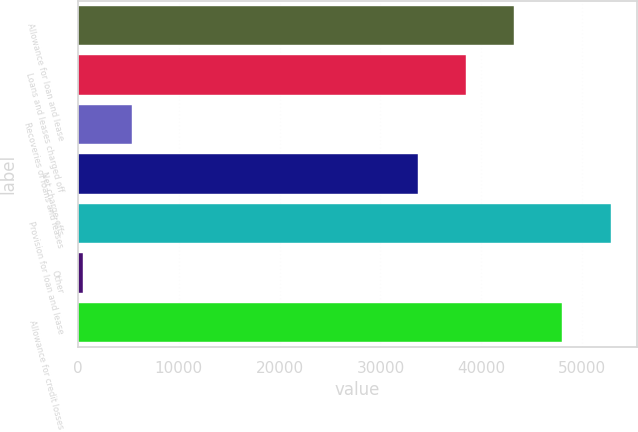Convert chart. <chart><loc_0><loc_0><loc_500><loc_500><bar_chart><fcel>Allowance for loan and lease<fcel>Loans and leases charged off<fcel>Recoveries of loans and leases<fcel>Net charge-offs<fcel>Provision for loan and lease<fcel>Other<fcel>Allowance for credit losses<nl><fcel>43251.4<fcel>38469.7<fcel>5330.7<fcel>33688<fcel>52814.8<fcel>549<fcel>48033.1<nl></chart> 